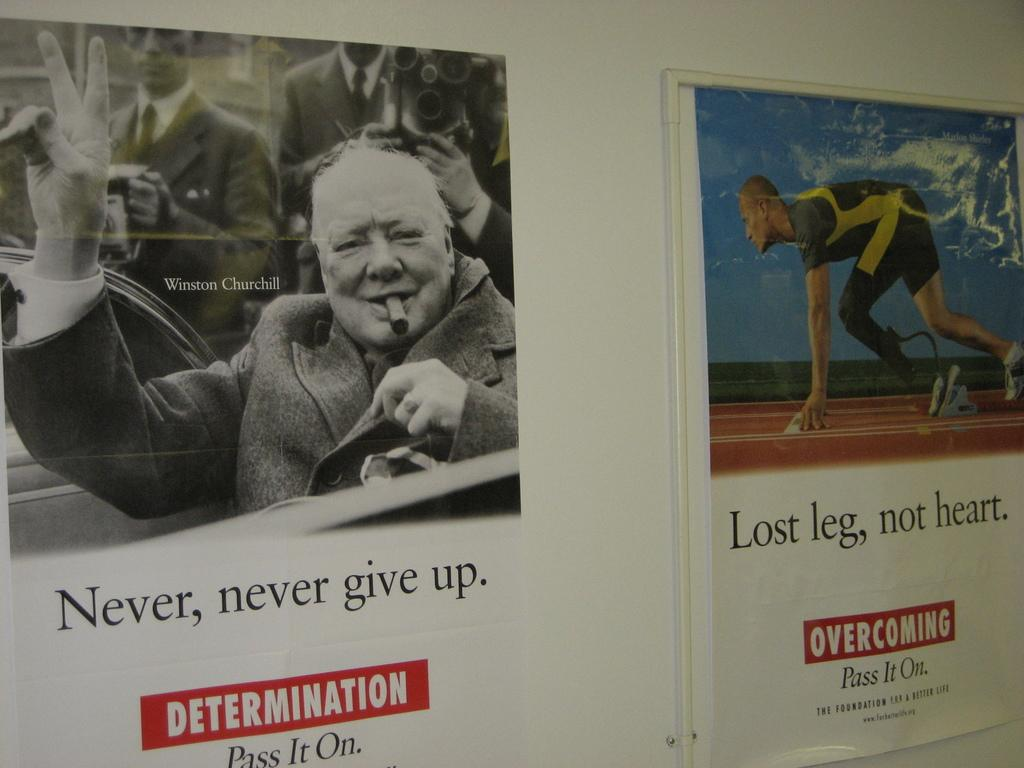What is attached to the wall in the image? There are posts on a wall in the image. What is depicted on the posts? There are people depicted on the posters. What can be found on the posters besides the images of people? There is writing on the posters. What type of polish is being applied to the tree in the image? There is no tree or polish present in the image; it features posts with people and writing on them. 